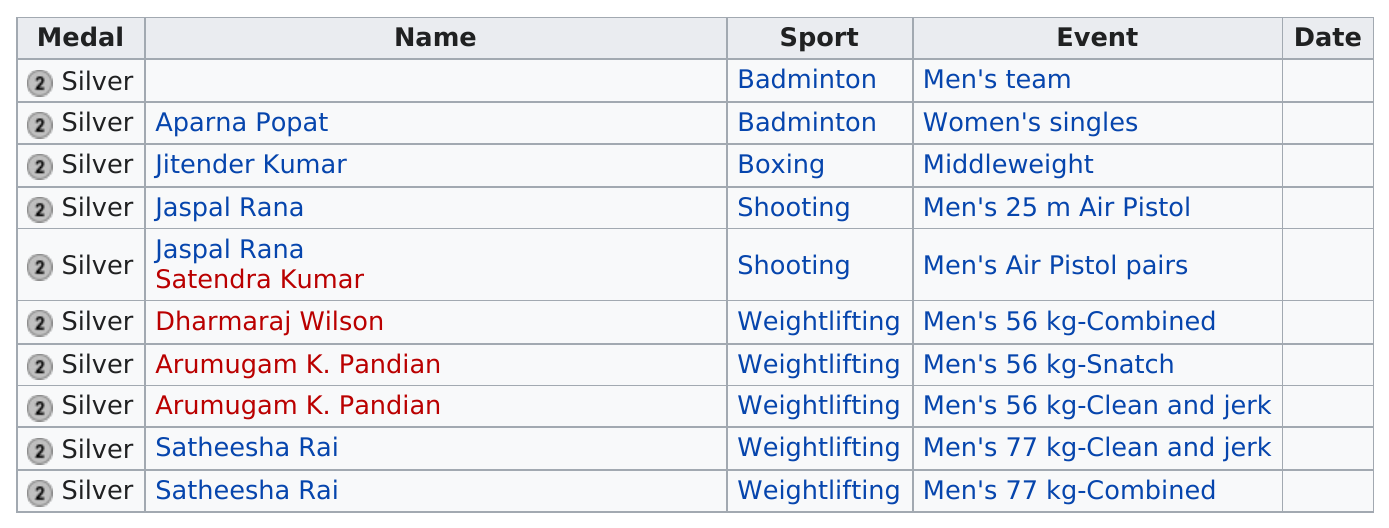Indicate a few pertinent items in this graphic. India won a total of 10 silver medals. Five silver metals were given for weightlifting. Seven different individuals were awarded silver medals. India won two silver medals in shooting at the event. In total, 4 silver medals were awarded to various sports. 